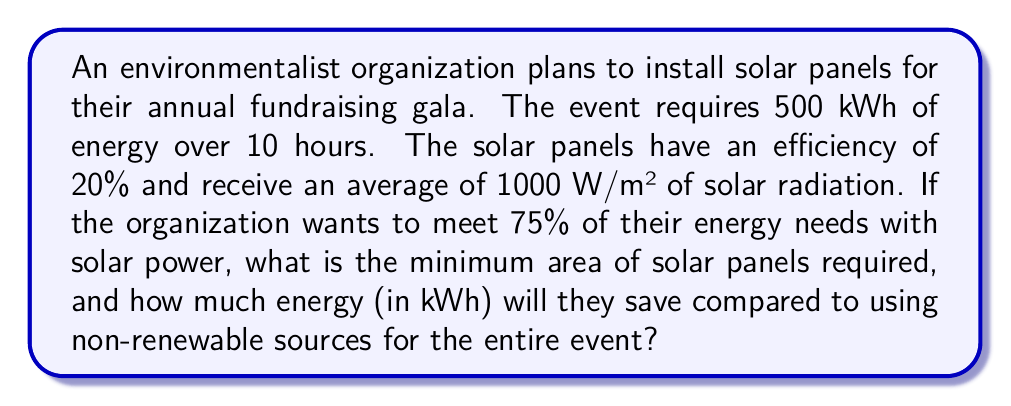Teach me how to tackle this problem. 1. Calculate the total energy required for the event:
   $500 \text{ kWh} = 500,000 \text{ Wh}$

2. Calculate the energy to be supplied by solar panels (75% of total):
   $E_{\text{solar}} = 0.75 \times 500,000 \text{ Wh} = 375,000 \text{ Wh}$

3. Calculate the energy received per square meter of solar panel in 10 hours:
   $E_{\text{received}} = 1000 \text{ W/m²} \times 10 \text{ h} = 10,000 \text{ Wh/m²}$

4. Calculate the energy produced per square meter of solar panel:
   $E_{\text{produced}} = 0.20 \times 10,000 \text{ Wh/m²} = 2,000 \text{ Wh/m²}$

5. Calculate the required area of solar panels:
   $$A = \frac{E_{\text{solar}}}{E_{\text{produced}}} = \frac{375,000 \text{ Wh}}{2,000 \text{ Wh/m²}} = 187.5 \text{ m²}$$

6. Calculate the energy saved compared to using non-renewable sources:
   $E_{\text{saved}} = 375,000 \text{ Wh} = 375 \text{ kWh}$
Answer: 187.5 m²; 375 kWh 